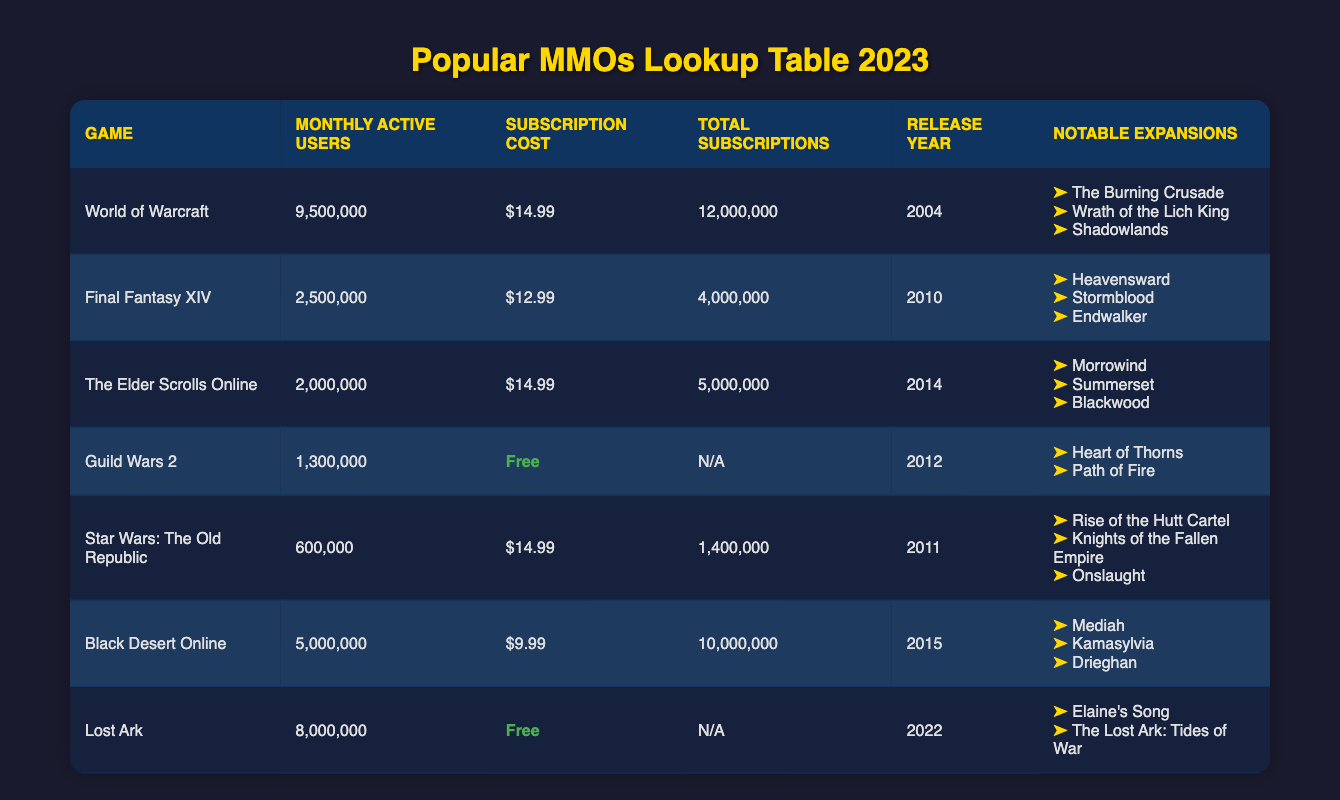What is the monthly active user count for World of Warcraft? You can find this information directly in the table under the "Monthly Active Users" column for World of Warcraft, which states that there are 9,500,000 users.
Answer: 9,500,000 Which game has the highest subscription cost per month? Looking through the "Subscription Cost" column, World of Warcraft has the highest subscription cost at $14.99, which is the maximum value listed in that column.
Answer: World of Warcraft What is the total number of subscriptions for Black Desert Online? The "Total Subscriptions" column for Black Desert Online shows a value of 10,000,000, which directly answers the question.
Answer: 10,000,000 How many games have more than 2 million monthly active users? By analyzing the "Monthly Active Users" column, there are five games (World of Warcraft, Final Fantasy XIV, Black Desert Online, Lost Ark) with more than 2 million users. We count them: World of Warcraft (9,500,000), Final Fantasy XIV (2,500,000), Black Desert Online (5,000,000), Lost Ark (8,000,000). This results in a total of four games.
Answer: 4 Is Star Wars: The Old Republic free to play? The table indicates that the subscription cost for Star Wars: The Old Republic is $14.99, which signifies that it is not free to play.
Answer: No What is the average subscription cost for the games listed in the table? Adding up the subscription costs: $14.99 (WoW) + $12.99 (FFXIV) + $14.99 (ESO) + $0 (GW2) + $14.99 (SWTOR) + $9.99 (BDO) + $0 (Lost Ark) equals $67.95. Dividing that by 7 (the total number of games) gives an average subscription cost of approximately $9.71.
Answer: $9.71 Which game has the least number of total subscriptions? The "Total Subscriptions" column only has values for games that require subscriptions. Guild Wars 2 and Lost Ark do not have any listed subscriptions. Checking the available values, Star Wars: The Old Republic has 1,400,000 subscriptions which is the least among those figures that are available.
Answer: Star Wars: The Old Republic Which two games have notable expansions that include "Heavensward"? Examining the notable expansions listed, "Heavensward" is found under the "Final Fantasy XIV" entry. The second reference is not present among the others; therefore, there is only one game featuring this expansion.
Answer: Final Fantasy XIV What is the difference in monthly active users between Lost Ark and The Elder Scrolls Online? Lost Ark has 8,000,000 monthly active users, while The Elder Scrolls Online has 2,000,000. The difference is calculated as 8,000,000 - 2,000,000 = 6,000,000.
Answer: 6,000,000 